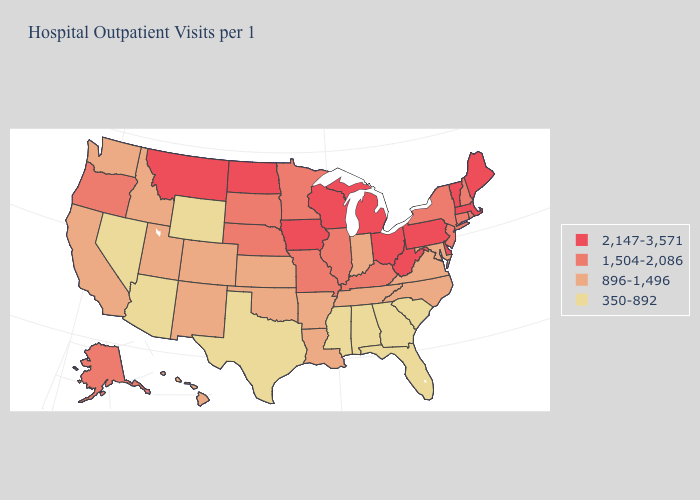What is the lowest value in states that border Nevada?
Short answer required. 350-892. Among the states that border Michigan , which have the lowest value?
Write a very short answer. Indiana. What is the value of Utah?
Concise answer only. 896-1,496. Does Arkansas have the highest value in the USA?
Answer briefly. No. Among the states that border New Jersey , does New York have the highest value?
Give a very brief answer. No. What is the value of Wyoming?
Keep it brief. 350-892. What is the lowest value in the Northeast?
Write a very short answer. 1,504-2,086. Does Rhode Island have a lower value than Vermont?
Keep it brief. Yes. Name the states that have a value in the range 896-1,496?
Concise answer only. Arkansas, California, Colorado, Hawaii, Idaho, Indiana, Kansas, Louisiana, Maryland, New Mexico, North Carolina, Oklahoma, Tennessee, Utah, Virginia, Washington. Name the states that have a value in the range 896-1,496?
Keep it brief. Arkansas, California, Colorado, Hawaii, Idaho, Indiana, Kansas, Louisiana, Maryland, New Mexico, North Carolina, Oklahoma, Tennessee, Utah, Virginia, Washington. What is the lowest value in states that border Indiana?
Concise answer only. 1,504-2,086. Name the states that have a value in the range 350-892?
Quick response, please. Alabama, Arizona, Florida, Georgia, Mississippi, Nevada, South Carolina, Texas, Wyoming. Name the states that have a value in the range 2,147-3,571?
Keep it brief. Delaware, Iowa, Maine, Massachusetts, Michigan, Montana, North Dakota, Ohio, Pennsylvania, Vermont, West Virginia, Wisconsin. Among the states that border Alabama , which have the lowest value?
Concise answer only. Florida, Georgia, Mississippi. Among the states that border Utah , which have the highest value?
Give a very brief answer. Colorado, Idaho, New Mexico. 